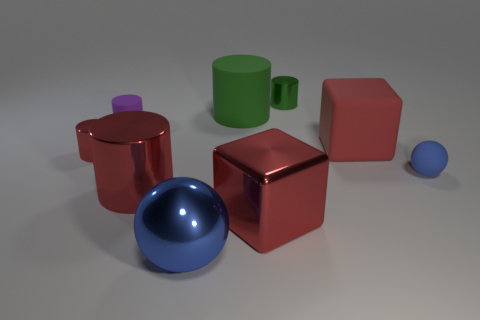Subtract all red blocks. How many green cylinders are left? 2 Subtract all small purple cylinders. How many cylinders are left? 4 Add 1 gray objects. How many objects exist? 10 Subtract all purple cylinders. How many cylinders are left? 4 Subtract all green cylinders. Subtract all red spheres. How many cylinders are left? 3 Subtract all spheres. How many objects are left? 7 Add 3 large metallic cylinders. How many large metallic cylinders exist? 4 Subtract 0 brown cylinders. How many objects are left? 9 Subtract all red objects. Subtract all red blocks. How many objects are left? 3 Add 3 spheres. How many spheres are left? 5 